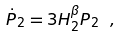Convert formula to latex. <formula><loc_0><loc_0><loc_500><loc_500>\dot { P } _ { 2 } = 3 H _ { 2 } ^ { \beta } P _ { 2 } \ ,</formula> 